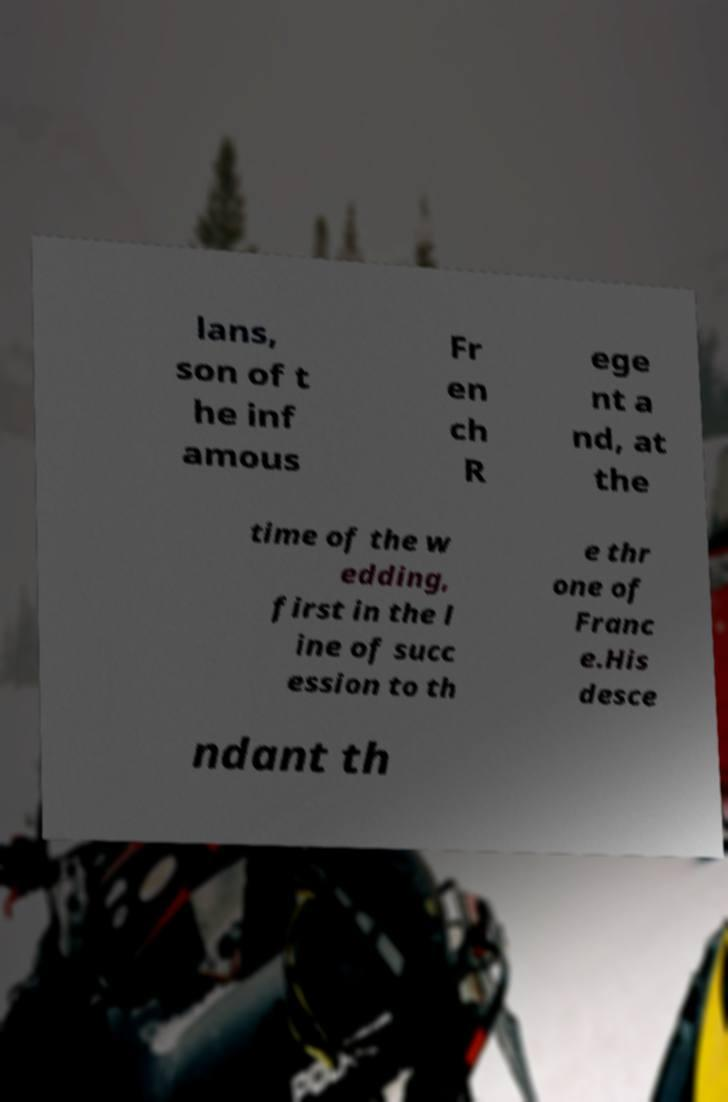Please identify and transcribe the text found in this image. lans, son of t he inf amous Fr en ch R ege nt a nd, at the time of the w edding, first in the l ine of succ ession to th e thr one of Franc e.His desce ndant th 